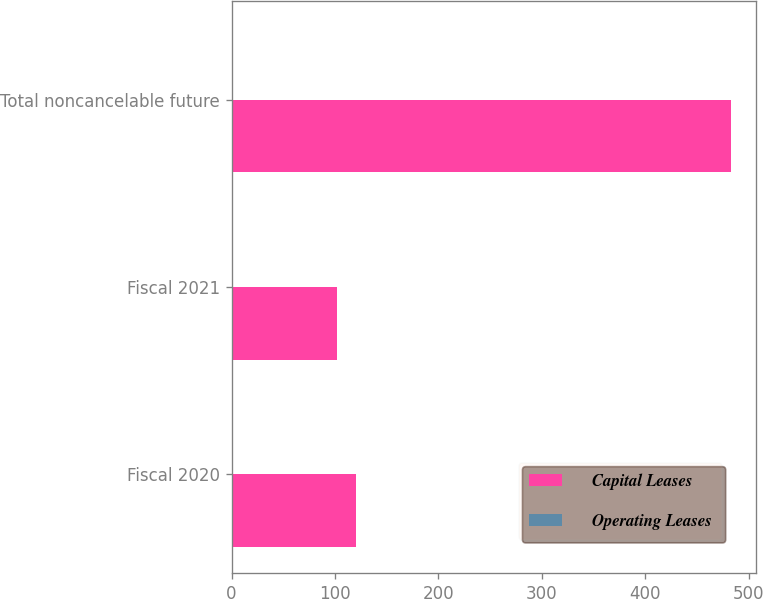Convert chart. <chart><loc_0><loc_0><loc_500><loc_500><stacked_bar_chart><ecel><fcel>Fiscal 2020<fcel>Fiscal 2021<fcel>Total noncancelable future<nl><fcel>Capital Leases<fcel>120<fcel>101.7<fcel>482.6<nl><fcel>Operating Leases<fcel>0.2<fcel>0.1<fcel>0.3<nl></chart> 